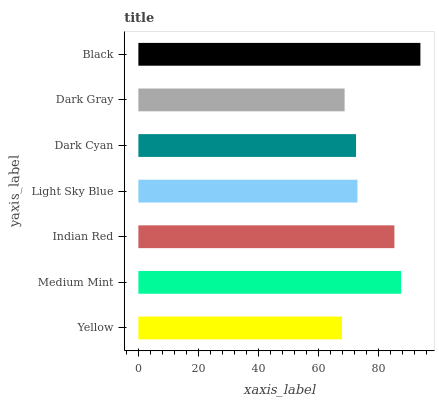Is Yellow the minimum?
Answer yes or no. Yes. Is Black the maximum?
Answer yes or no. Yes. Is Medium Mint the minimum?
Answer yes or no. No. Is Medium Mint the maximum?
Answer yes or no. No. Is Medium Mint greater than Yellow?
Answer yes or no. Yes. Is Yellow less than Medium Mint?
Answer yes or no. Yes. Is Yellow greater than Medium Mint?
Answer yes or no. No. Is Medium Mint less than Yellow?
Answer yes or no. No. Is Light Sky Blue the high median?
Answer yes or no. Yes. Is Light Sky Blue the low median?
Answer yes or no. Yes. Is Dark Cyan the high median?
Answer yes or no. No. Is Yellow the low median?
Answer yes or no. No. 